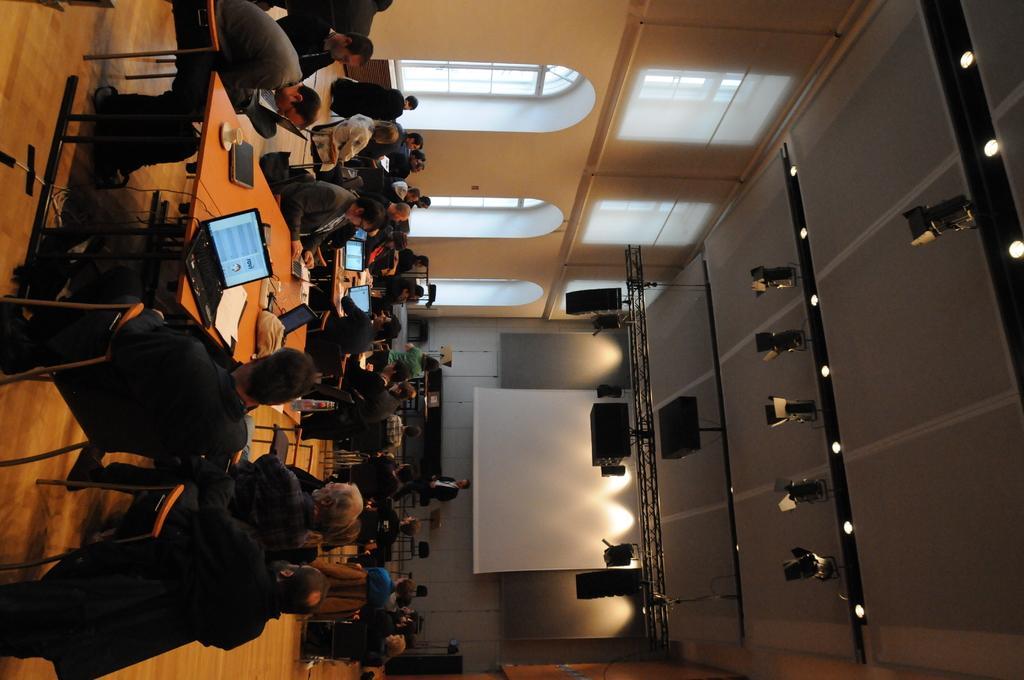How would you summarize this image in a sentence or two? In this image I can see a group of people sitting on the chairs. I can see laptop,papers,cup,saucer and some objects on the table. I can see white color screen and ash color wall. We can see building and windows. Top I can see lights. 